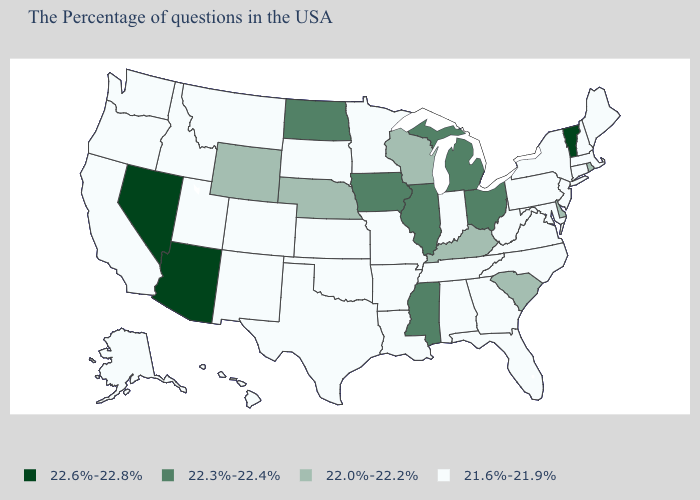What is the value of North Dakota?
Be succinct. 22.3%-22.4%. Name the states that have a value in the range 22.3%-22.4%?
Keep it brief. Ohio, Michigan, Illinois, Mississippi, Iowa, North Dakota. Name the states that have a value in the range 22.0%-22.2%?
Short answer required. Rhode Island, Delaware, South Carolina, Kentucky, Wisconsin, Nebraska, Wyoming. What is the value of North Dakota?
Give a very brief answer. 22.3%-22.4%. What is the value of Ohio?
Quick response, please. 22.3%-22.4%. Name the states that have a value in the range 22.6%-22.8%?
Keep it brief. Vermont, Arizona, Nevada. Name the states that have a value in the range 22.6%-22.8%?
Answer briefly. Vermont, Arizona, Nevada. Does Iowa have the highest value in the MidWest?
Be succinct. Yes. Among the states that border Massachusetts , which have the lowest value?
Answer briefly. New Hampshire, Connecticut, New York. Name the states that have a value in the range 21.6%-21.9%?
Answer briefly. Maine, Massachusetts, New Hampshire, Connecticut, New York, New Jersey, Maryland, Pennsylvania, Virginia, North Carolina, West Virginia, Florida, Georgia, Indiana, Alabama, Tennessee, Louisiana, Missouri, Arkansas, Minnesota, Kansas, Oklahoma, Texas, South Dakota, Colorado, New Mexico, Utah, Montana, Idaho, California, Washington, Oregon, Alaska, Hawaii. What is the value of Pennsylvania?
Short answer required. 21.6%-21.9%. What is the value of Louisiana?
Write a very short answer. 21.6%-21.9%. What is the lowest value in states that border Virginia?
Short answer required. 21.6%-21.9%. 